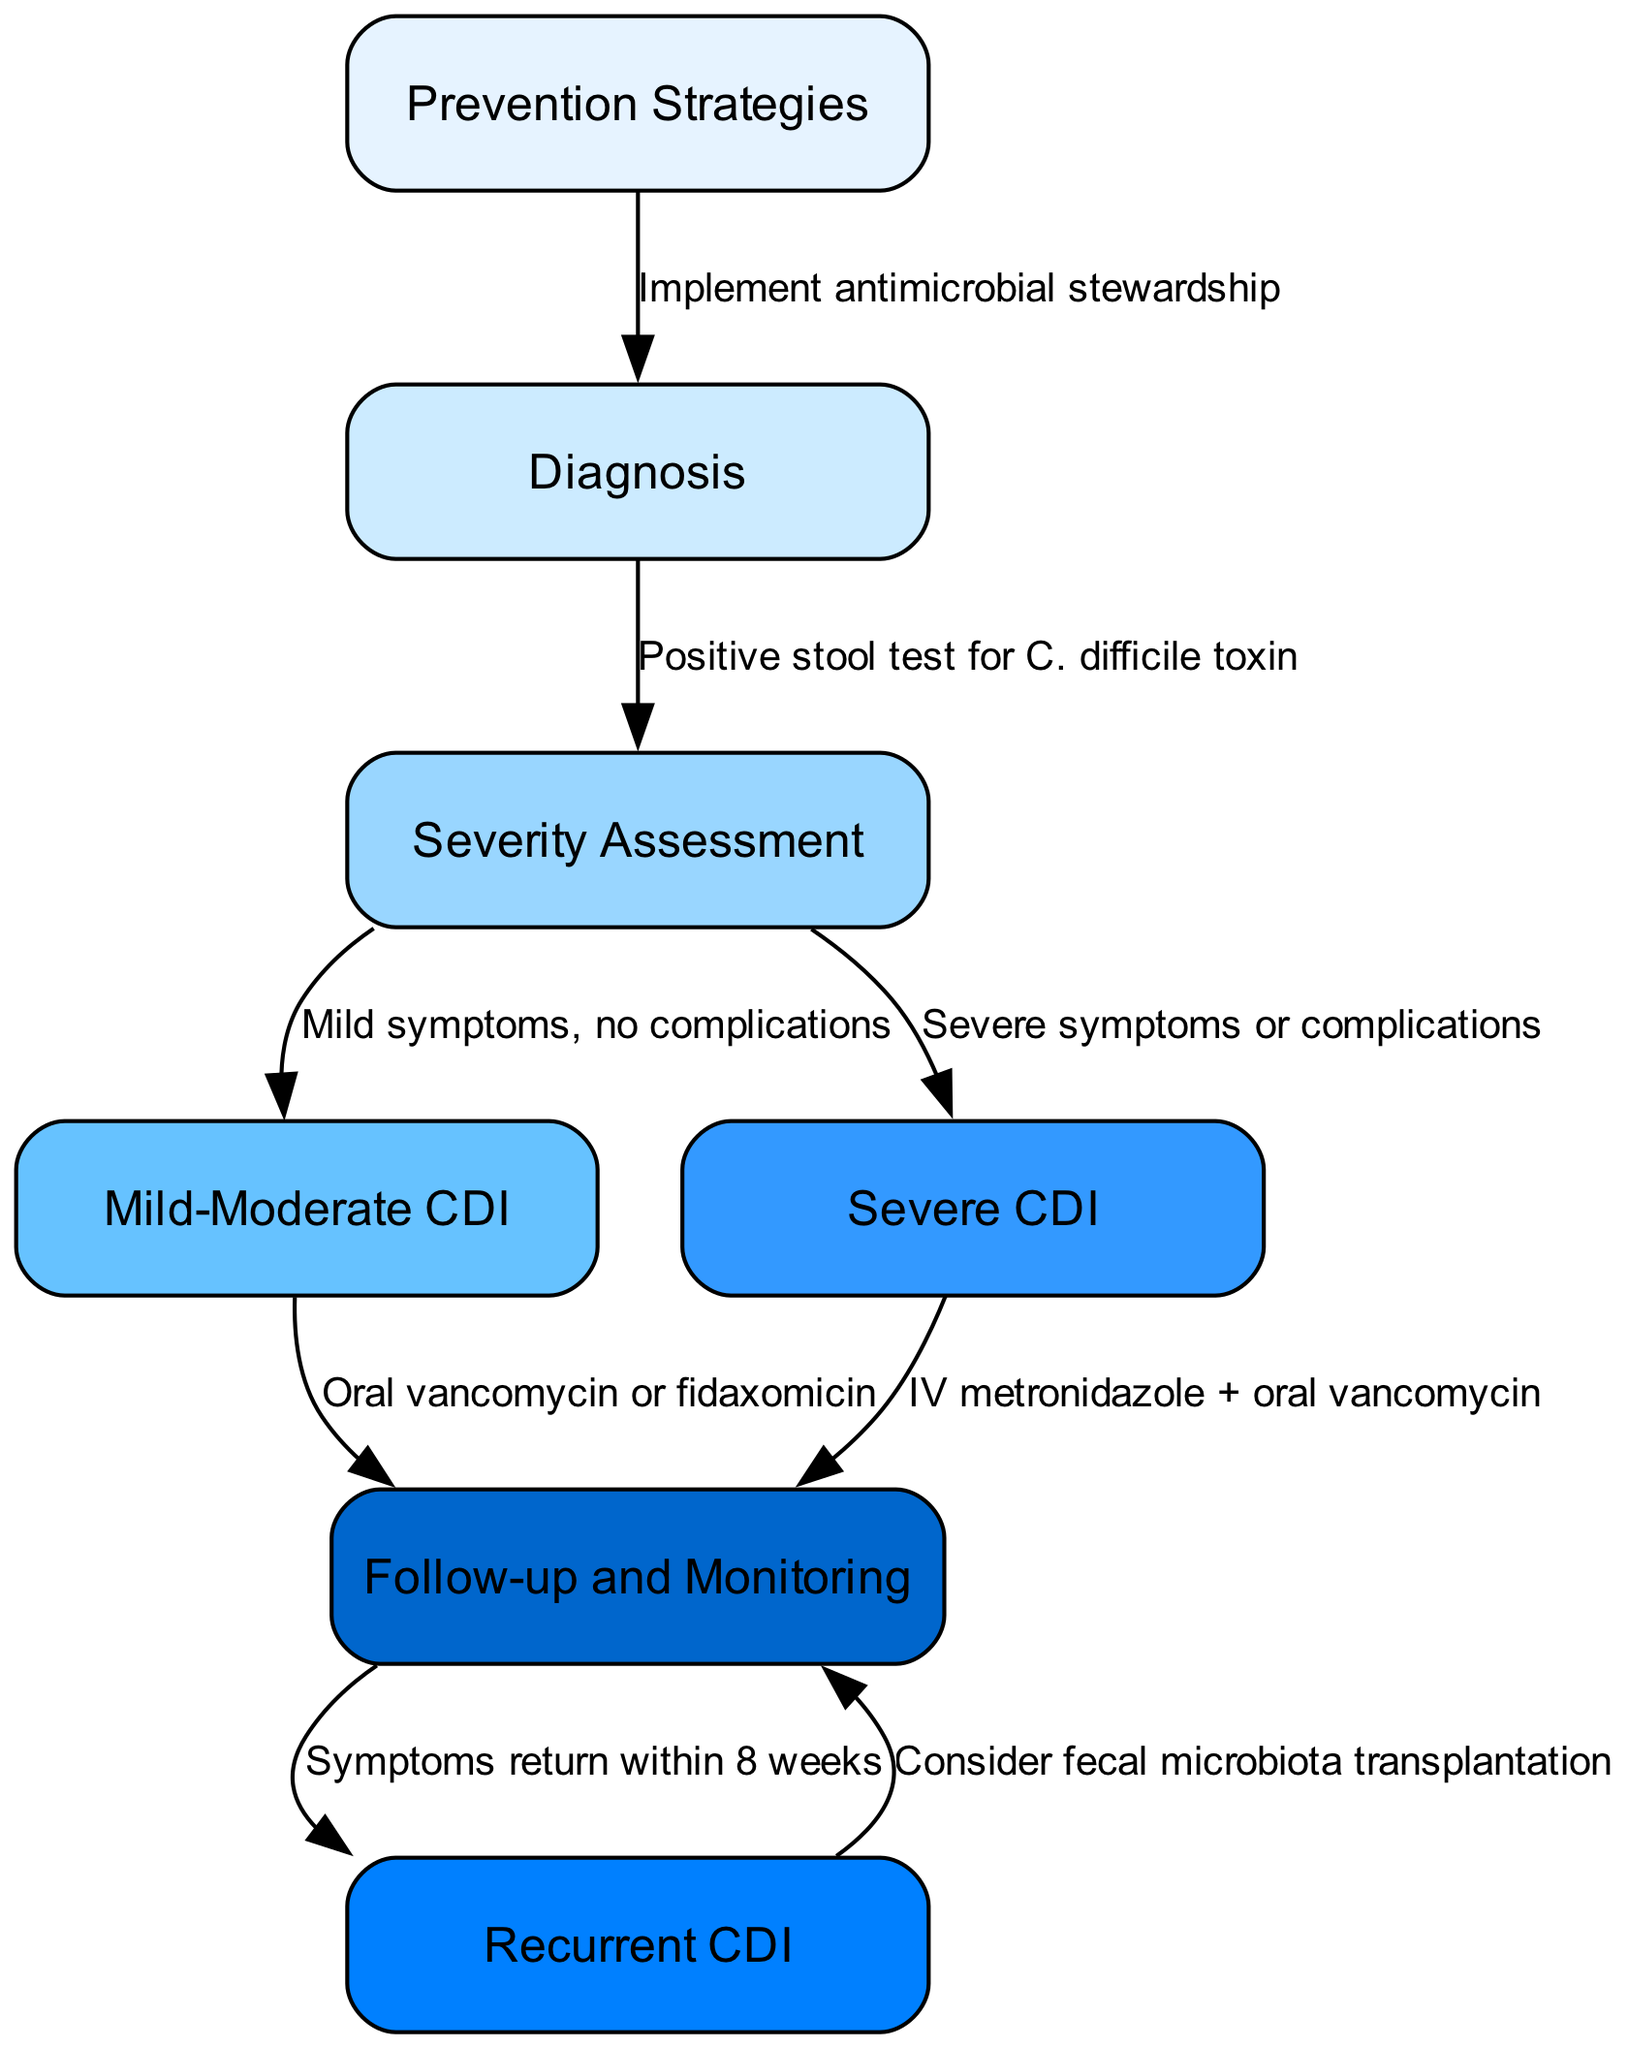What is the first step in managing Clostridioides difficile infection? The first step in the clinical pathway is "Prevention Strategies," which is indicated as the starting point before diagnosis occurs.
Answer: Prevention Strategies How many nodes are present in the clinical pathway diagram? By counting the nodes listed in the diagram, there are a total of 7 nodes that outline the management steps and outcomes.
Answer: 7 What condition is indicated by a positive stool test for C. difficile toxin? A positive stool test for C. difficile toxin leads to the next step, which is "Assessment" for determining the severity of the infection.
Answer: Assessment Which treatment is recommended for mild-moderate CDI? The management for mild-moderate CDI includes the use of either "Oral vancomycin or fidaxomicin" based on the clinical pathway.
Answer: Oral vancomycin or fidaxomicin If a patient has severe symptoms or complications, what is the next recommended step? For patients with severe CDI, the pathway indicates that they should receive "IV metronidazole + oral vancomycin" to manage their condition effectively.
Answer: IV metronidazole + oral vancomycin What happens if symptoms return within 8 weeks after follow-up? If symptoms return within 8 weeks following treatment, "Consider fecal microbiota transplantation" is advised as per the pathway for managing recurrent CDI cases.
Answer: Consider fecal microbiota transplantation How are prevention strategies connected to diagnosis in the clinical pathway? The connection between "Prevention Strategies" and "Diagnosis" occurs through the implementation of "antimicrobial stewardship," which aims to reduce the incidence of CDI.
Answer: Implement antimicrobial stewardship What action should be taken after assessing the severity of the infection? After assessing the severity, the next steps involve either managing mild-moderate or severe CDI, depending on the assessment outcomes.
Answer: Follow-up decisions based on severity What is the suggested follow-up action for recurrent CDI? The pathway specifies that for recurrent CDI, a follow-up action is to "Consider fecal microbiota transplantation," which acts as a treatment option for recurrence.
Answer: Consider fecal microbiota transplantation 